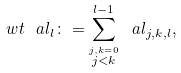Convert formula to latex. <formula><loc_0><loc_0><loc_500><loc_500>\ w t \ a l _ { l } \colon = \sum _ { \stackrel { j , k = 0 } { j < k } } ^ { l - 1 } \ a l _ { j , k , l } ,</formula> 